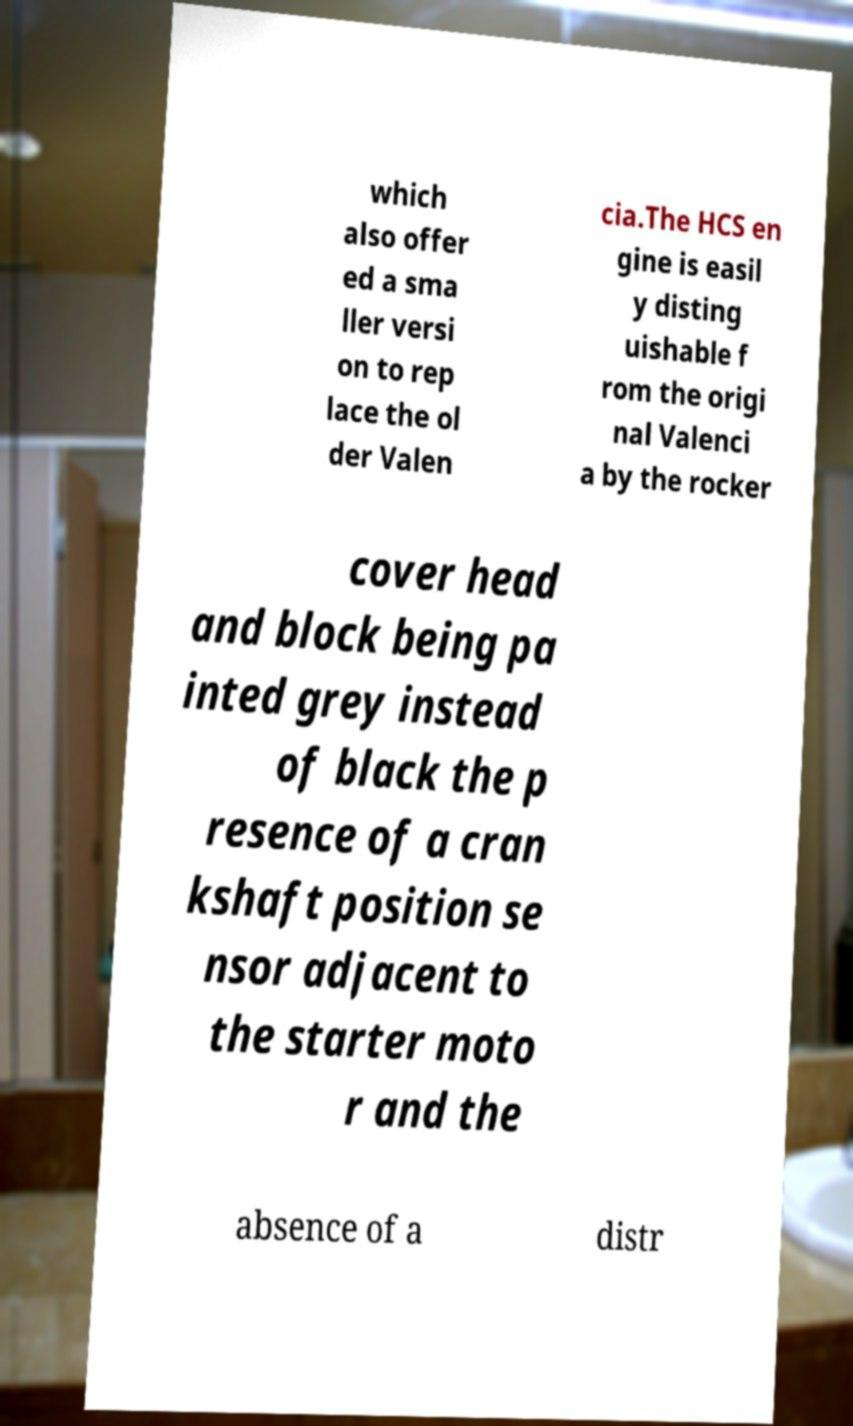Please read and relay the text visible in this image. What does it say? which also offer ed a sma ller versi on to rep lace the ol der Valen cia.The HCS en gine is easil y disting uishable f rom the origi nal Valenci a by the rocker cover head and block being pa inted grey instead of black the p resence of a cran kshaft position se nsor adjacent to the starter moto r and the absence of a distr 